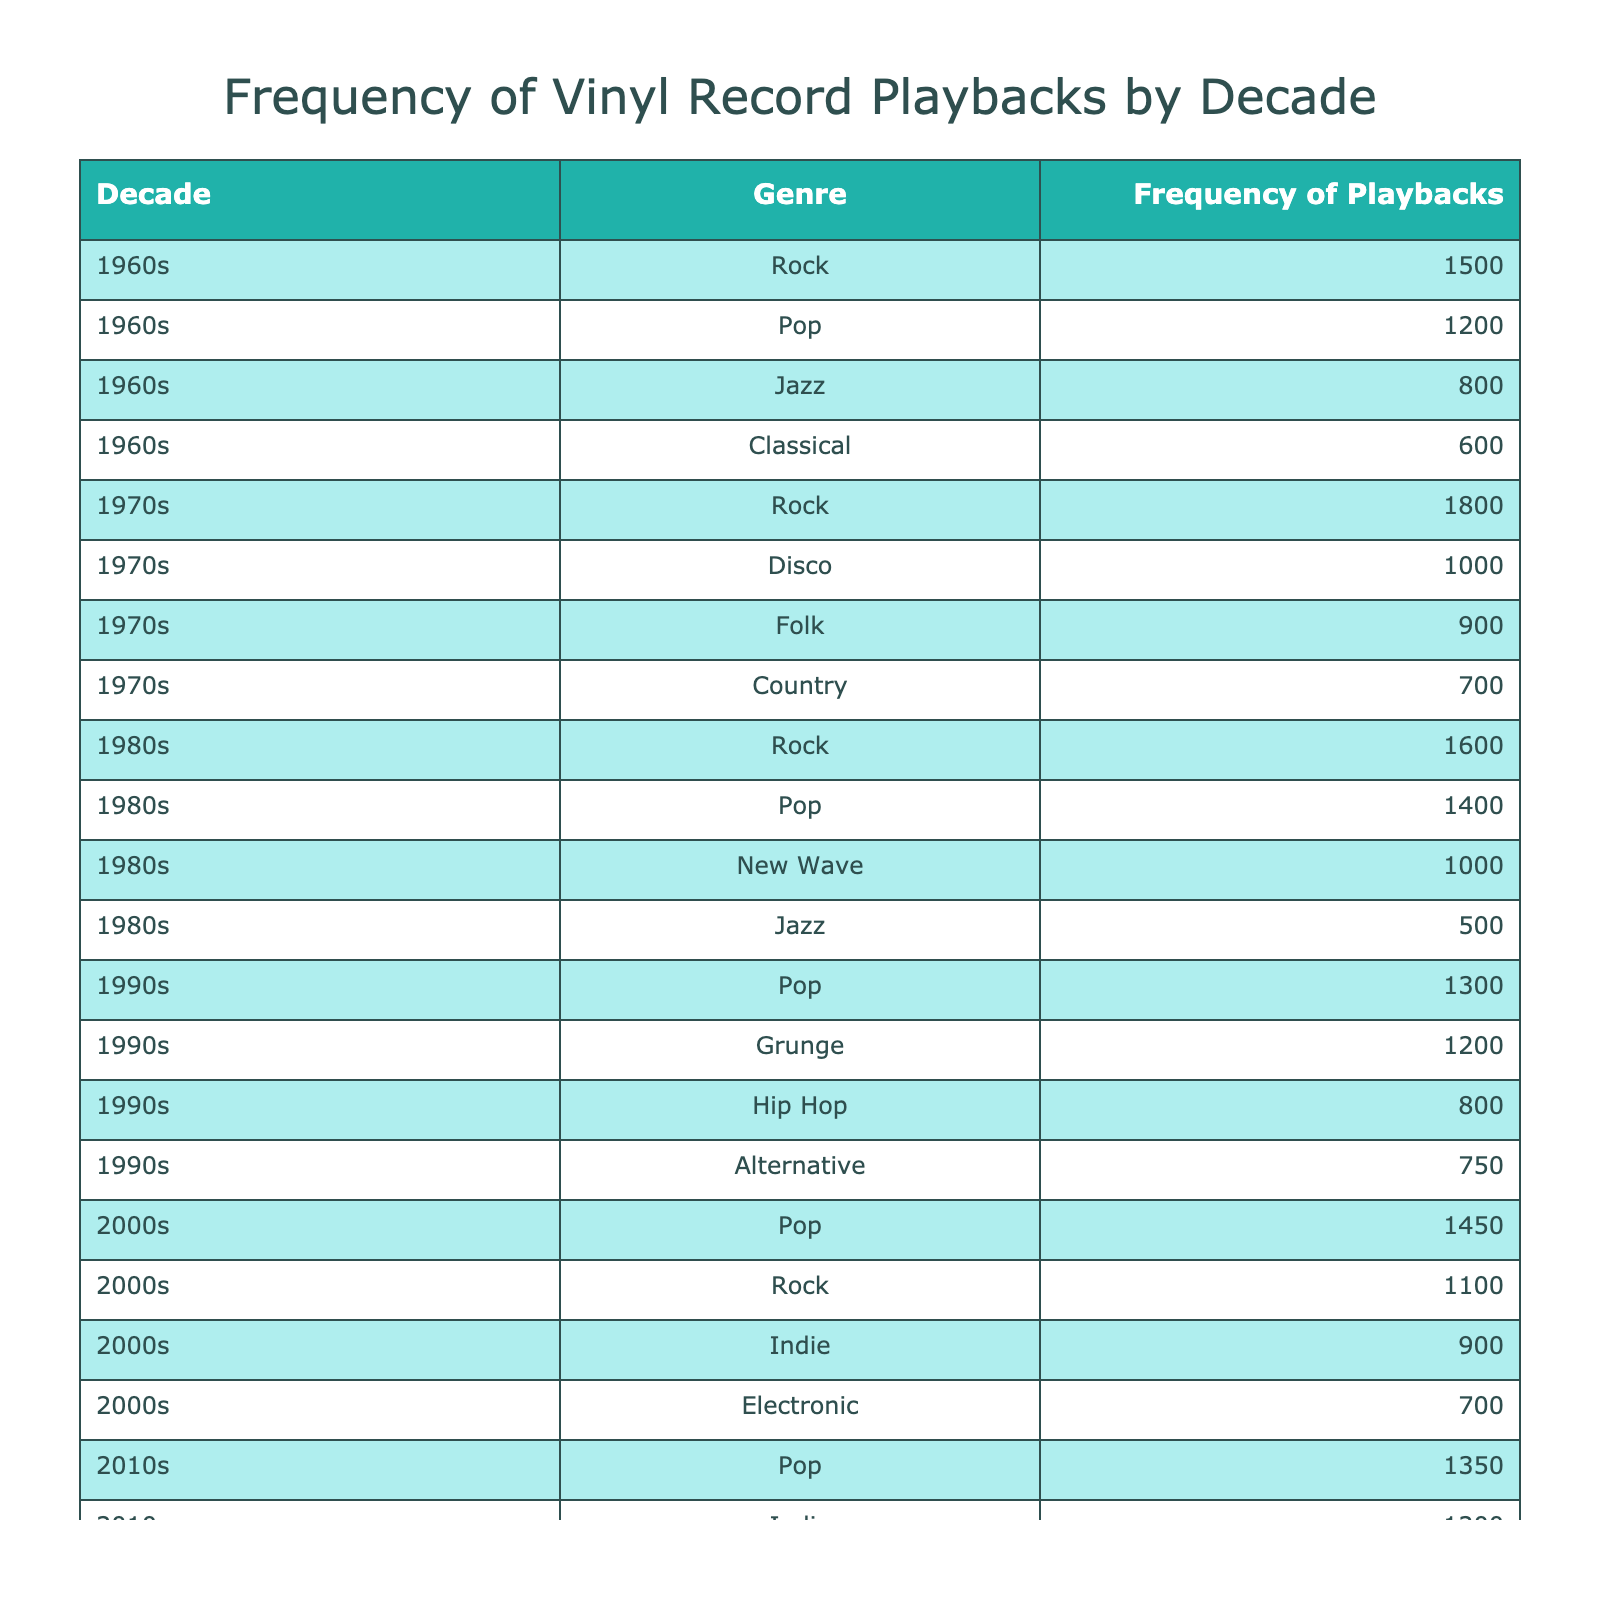What genre had the highest frequency of playbacks in the 1970s? In the 1970s, we look at the data in that specific decade, identifying the genre with the highest playback frequency. Examining the values for that decade, the highest frequency is for Rock with 1800 playbacks.
Answer: Rock How many total playbacks were recorded for Jazz across all decades? To find the total playbacks for Jazz, we sum the frequencies listed under the Jazz genre for each decade: 800 (1960s) + 500 (1980s) = 1300.
Answer: 1300 Which decade had the lowest playback frequency for Pop music? We need to examine the Pop rows across all decades and find the one with the lowest value. The frequencies for Pop are: 1200 (1960s), 1400 (1980s), 1300 (1990s), 1450 (2000s), and 1350 (2010s). The lowest value is from the 1960s at 1200.
Answer: 1960s What is the average frequency of playbacks for Rock music across all decades? To calculate the average for Rock, we find its frequencies: 1500 (1960s), 1800 (1970s), 1600 (1980s), 1100 (2000s). The sum is (1500 + 1800 + 1600 + 1100) = 6000. There are 4 entries, so the average is 6000/4 = 1500.
Answer: 1500 Did more vinyl records get played in the 2000s for Pop than in the 1990s? We compare the playback frequencies for Pop in both decades. In the 2000s, the frequency is 1450, while in the 1990s it is 1300. Since 1450 is greater than 1300, the answer is yes.
Answer: Yes Which genre in the 1980s had the lowest playbacks? Looking specifically at the 1980s, we see the genres and their frequencies: Rock (1600), Pop (1400), New Wave (1000), Jazz (500). The lowest frequency here is Jazz with 500.
Answer: Jazz How many more total playbacks for Folk are there in the 1970s compared to the 2010s? For Folk, we find the frequencies: 900 (1970s) and 800 (2010s). To find the difference, we subtract the 2010s frequency from the 1970s frequency, which is 900 - 800 = 100.
Answer: 100 What is the total frequency of playbacks for all genres across the 1960s? We sum up the playback frequencies for all genres in the 1960s: 1500 (Rock) + 1200 (Pop) + 800 (Jazz) + 600 (Classical) = 3100.
Answer: 3100 Which decade had the highest total playbacks across all genres? To find the total for each decade, we sum their respective frequencies: 
1960s: 1500 + 1200 + 800 + 600 = 3100
1970s: 1800 + 1000 + 700 + 900 = 4400
1980s: 1600 + 1400 + 1000 + 500 = 3500
1990s: 1200 + 1300 + 800 + 750 = 3050
2000s: 1100 + 1450 + 900 + 700 = 4150
2010s: 950 + 1350 + 1200 + 800 = 3350
The highest total is in the 1970s with 4400.
Answer: 1970s 